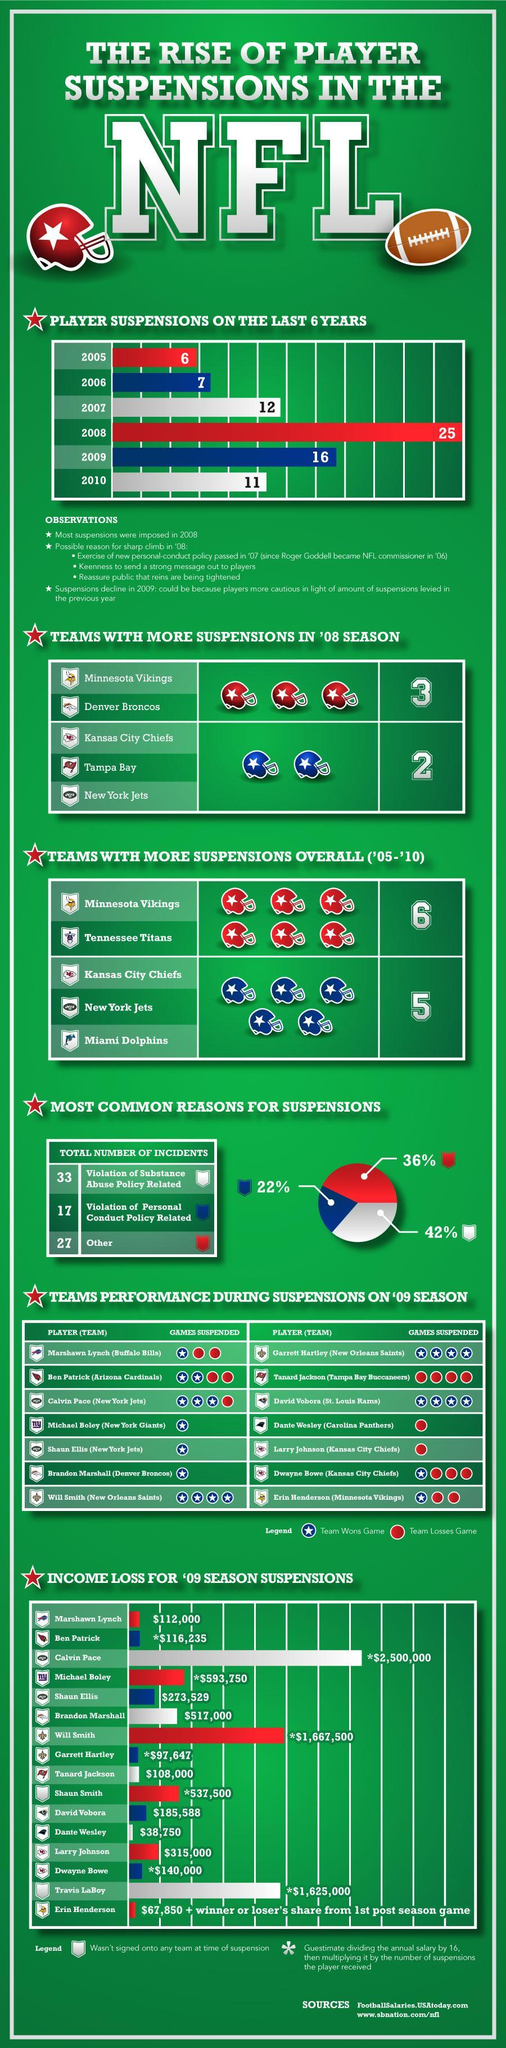Which are the teams that had over 5 suspensions between '05-'10
Answer the question with a short phrase. Minnesota Vikings, Tennessee Titans Which teams had 2 suspensions in '08 season Kansas City Chiefs, Tampa Bay, New York Jets What is the total income loss in dollar for Dante Wesley and Marshawn Lynch 150750 Which teams had 3 suspensions in '08 season Minnesota Vikings, Denver Broncos Which years were the suspension less than 10 2005, 2006 WHat % suspension was due to violation of personal conduct policy related 22% WHich years were the suspension over 15 2008, 2009 